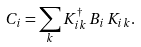<formula> <loc_0><loc_0><loc_500><loc_500>C _ { i } = \sum _ { k } K _ { i k } ^ { \dag } \, B _ { i } \, K _ { i k } .</formula> 